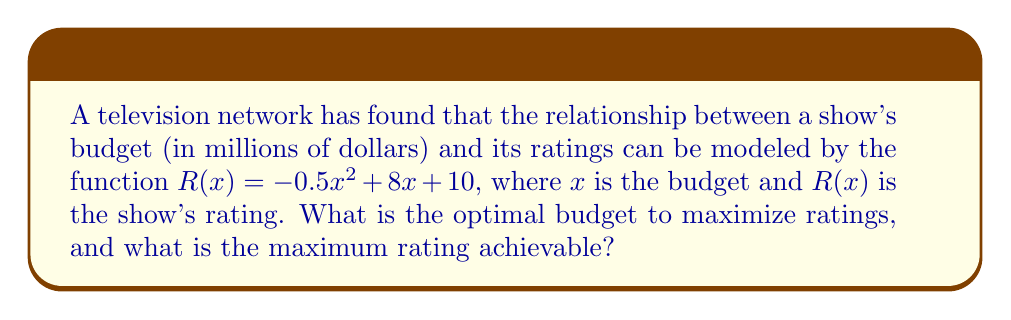Teach me how to tackle this problem. To find the optimal budget and maximum rating, we need to follow these steps:

1. Find the derivative of the ratings function:
   $$R'(x) = -x + 8$$

2. Set the derivative equal to zero to find the critical point:
   $$-x + 8 = 0$$
   $$x = 8$$

3. Verify that this critical point is a maximum by checking the second derivative:
   $$R''(x) = -1$$
   Since $R''(x)$ is negative, the critical point is indeed a maximum.

4. The optimal budget is therefore $x = 8$ million dollars.

5. To find the maximum rating, substitute $x = 8$ into the original function:
   $$R(8) = -0.5(8)^2 + 8(8) + 10$$
   $$= -0.5(64) + 64 + 10$$
   $$= -32 + 64 + 10$$
   $$= 42$$

Therefore, the maximum rating achievable is 42.
Answer: Optimal budget: $8 million; Maximum rating: 42 